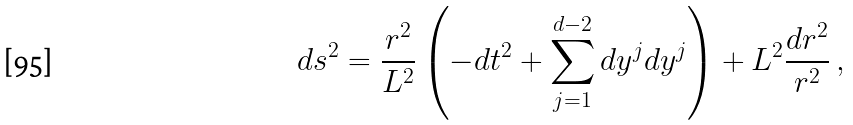<formula> <loc_0><loc_0><loc_500><loc_500>d s ^ { 2 } = \frac { r ^ { 2 } } { L ^ { 2 } } \left ( - d t ^ { 2 } + \sum _ { j = 1 } ^ { d - 2 } d y ^ { j } d y ^ { j } \right ) + L ^ { 2 } \frac { d r ^ { 2 } } { r ^ { 2 } } \, ,</formula> 